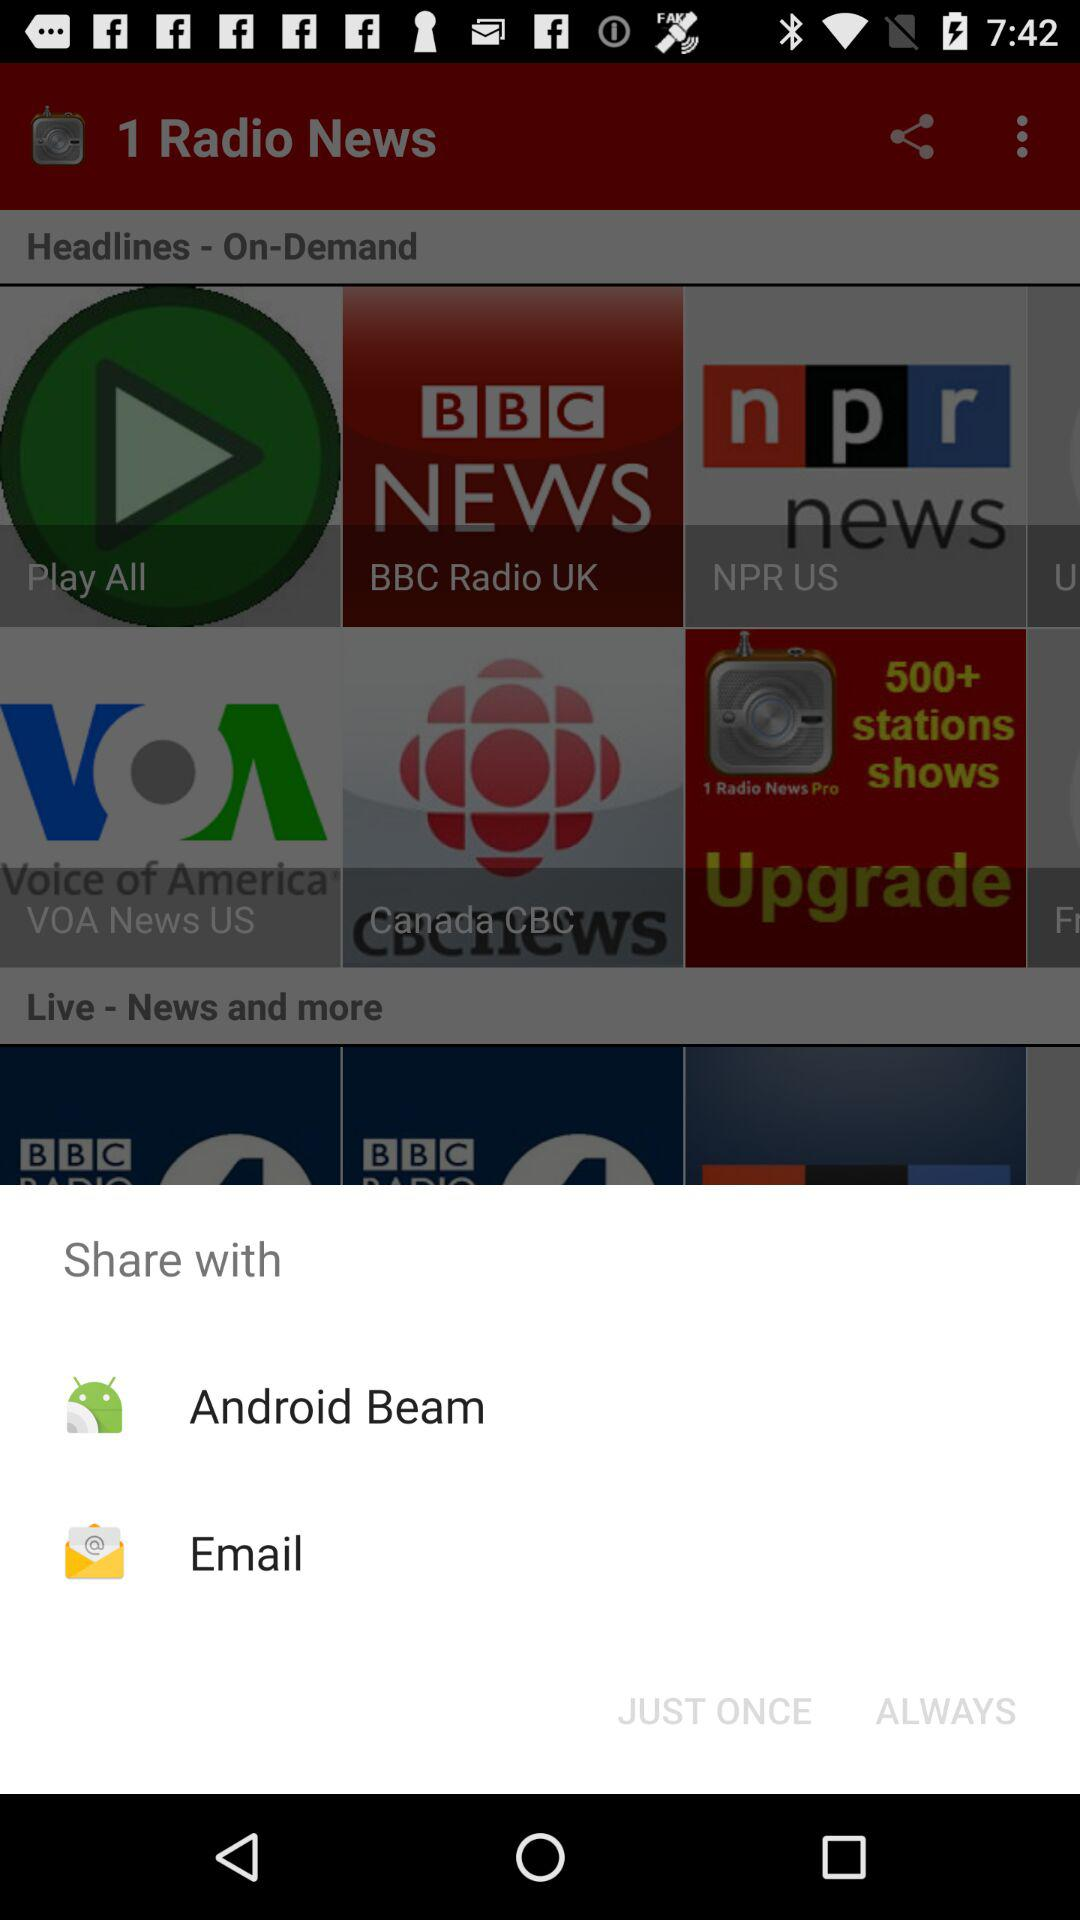What applications are used to share the news? The applications are "Android Beam" and "Email". 